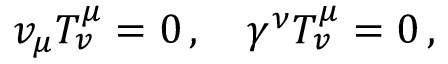Convert formula to latex. <formula><loc_0><loc_0><loc_500><loc_500>v _ { \mu } T _ { v } ^ { \mu } = 0 \, , \quad \gamma ^ { \nu } T _ { v } ^ { \mu } = 0 \, ,</formula> 